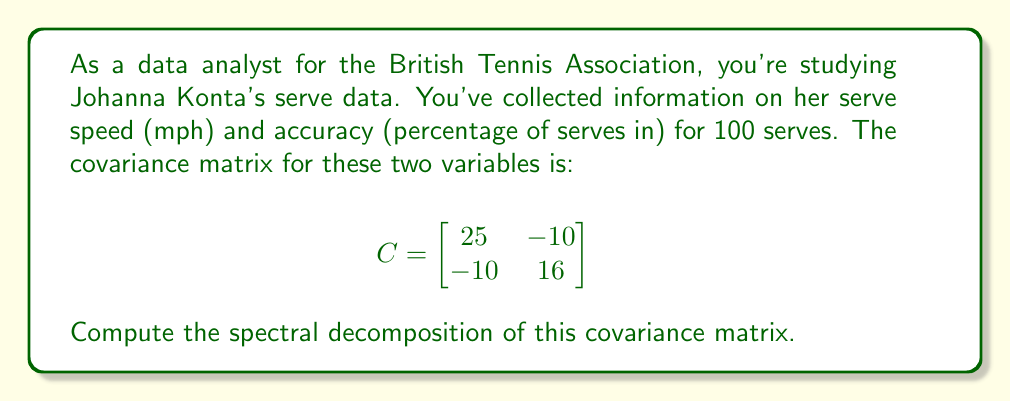Can you solve this math problem? To compute the spectral decomposition of the covariance matrix C, we need to find its eigenvalues and eigenvectors. The steps are as follows:

1) Find the eigenvalues by solving the characteristic equation:
   $$det(C - \lambda I) = 0$$
   $$\begin{vmatrix}
   25 - \lambda & -10 \\
   -10 & 16 - \lambda
   \end{vmatrix} = 0$$
   $$(25 - \lambda)(16 - \lambda) - 100 = 0$$
   $$\lambda^2 - 41\lambda + 300 = 0$$

2) Solve this quadratic equation:
   $$\lambda = \frac{41 \pm \sqrt{41^2 - 4(300)}}{2} = \frac{41 \pm \sqrt{481}}{2}$$
   $$\lambda_1 = \frac{41 + \sqrt{481}}{2} \approx 36.97$$
   $$\lambda_2 = \frac{41 - \sqrt{481}}{2} \approx 4.03$$

3) Find the eigenvectors for each eigenvalue:
   For $\lambda_1 \approx 36.97$:
   $$(C - \lambda_1 I)v_1 = 0$$
   $$\begin{bmatrix}
   -11.97 & -10 \\
   -10 & -20.97
   \end{bmatrix}\begin{bmatrix}
   x \\
   y
   \end{bmatrix} = \begin{bmatrix}
   0 \\
   0
   \end{bmatrix}$$
   Solving this gives us $v_1 \approx [0.8944, -0.4472]^T$

   For $\lambda_2 \approx 4.03$:
   $$(C - \lambda_2 I)v_2 = 0$$
   $$\begin{bmatrix}
   20.97 & -10 \\
   -10 & 11.97
   \end{bmatrix}\begin{bmatrix}
   x \\
   y
   \end{bmatrix} = \begin{bmatrix}
   0 \\
   0
   \end{bmatrix}$$
   Solving this gives us $v_2 \approx [0.4472, 0.8944]^T$

4) The spectral decomposition is given by:
   $$C = V\Lambda V^T$$
   where $V$ is the matrix of eigenvectors and $\Lambda$ is the diagonal matrix of eigenvalues.

   $$C \approx \begin{bmatrix}
   0.8944 & 0.4472 \\
   -0.4472 & 0.8944
   \end{bmatrix}
   \begin{bmatrix}
   36.97 & 0 \\
   0 & 4.03
   \end{bmatrix}
   \begin{bmatrix}
   0.8944 & -0.4472 \\
   0.4472 & 0.8944
   \end{bmatrix}$$
Answer: $$C \approx \begin{bmatrix}
0.8944 & 0.4472 \\
-0.4472 & 0.8944
\end{bmatrix}
\begin{bmatrix}
36.97 & 0 \\
0 & 4.03
\end{bmatrix}
\begin{bmatrix}
0.8944 & -0.4472 \\
0.4472 & 0.8944
\end{bmatrix}$$ 